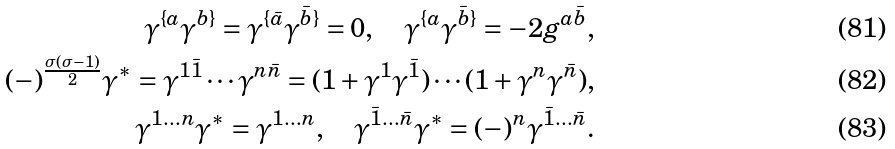<formula> <loc_0><loc_0><loc_500><loc_500>\gamma ^ { \{ a } \gamma ^ { b \} } = \gamma ^ { \{ \bar { a } } \gamma ^ { \bar { b } \} } = 0 , \quad \gamma ^ { \{ a } \gamma ^ { \bar { b } \} } = - 2 g ^ { a \bar { b } } , \\ ( - ) ^ { \frac { \sigma ( \sigma - 1 ) } { 2 } } \gamma ^ { * } = \gamma ^ { 1 \bar { 1 } } \cdots \gamma ^ { n \bar { n } } = ( \mathbb { m } { 1 } + \gamma ^ { 1 } \gamma ^ { \bar { 1 } } ) \cdots ( \mathbb { m } { 1 } + \gamma ^ { n } \gamma ^ { \bar { n } } ) , \\ \gamma ^ { 1 \dots n } \gamma ^ { * } = \gamma ^ { 1 \dots n } , \quad \gamma ^ { \bar { 1 } \dots \bar { n } } \gamma ^ { * } = ( - ) ^ { n } \gamma ^ { \bar { 1 } \dots \bar { n } } .</formula> 